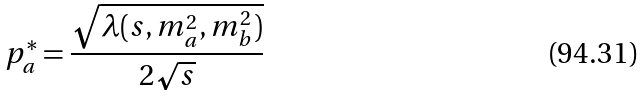Convert formula to latex. <formula><loc_0><loc_0><loc_500><loc_500>p _ { a } ^ { * } = \frac { \sqrt { \lambda ( s , m _ { a } ^ { 2 } , m _ { b } ^ { 2 } ) } } { 2 \sqrt { s } }</formula> 